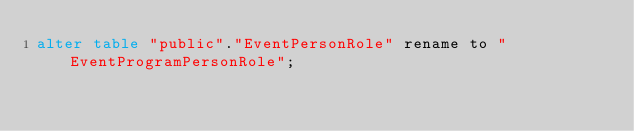Convert code to text. <code><loc_0><loc_0><loc_500><loc_500><_SQL_>alter table "public"."EventPersonRole" rename to "EventProgramPersonRole";
</code> 